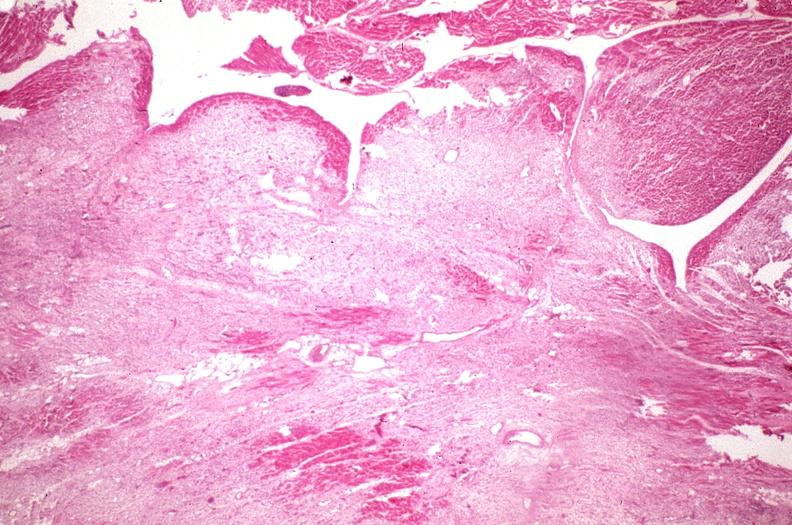where is this in?
Answer the question using a single word or phrase. In heart 